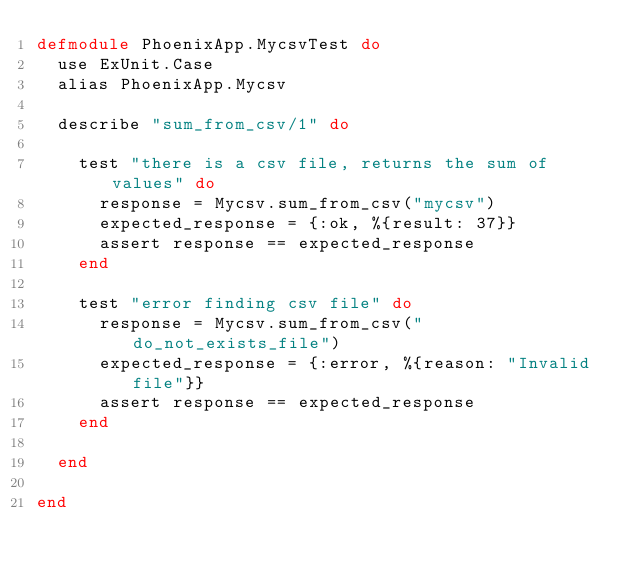Convert code to text. <code><loc_0><loc_0><loc_500><loc_500><_Elixir_>defmodule PhoenixApp.MycsvTest do
  use ExUnit.Case
  alias PhoenixApp.Mycsv

  describe "sum_from_csv/1" do

    test "there is a csv file, returns the sum of values" do
      response = Mycsv.sum_from_csv("mycsv")
      expected_response = {:ok, %{result: 37}}
      assert response == expected_response
    end

    test "error finding csv file" do
      response = Mycsv.sum_from_csv("do_not_exists_file")
      expected_response = {:error, %{reason: "Invalid file"}}
      assert response == expected_response
    end

  end

end
</code> 